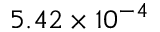<formula> <loc_0><loc_0><loc_500><loc_500>5 . 4 2 \times 1 0 ^ { - 4 }</formula> 